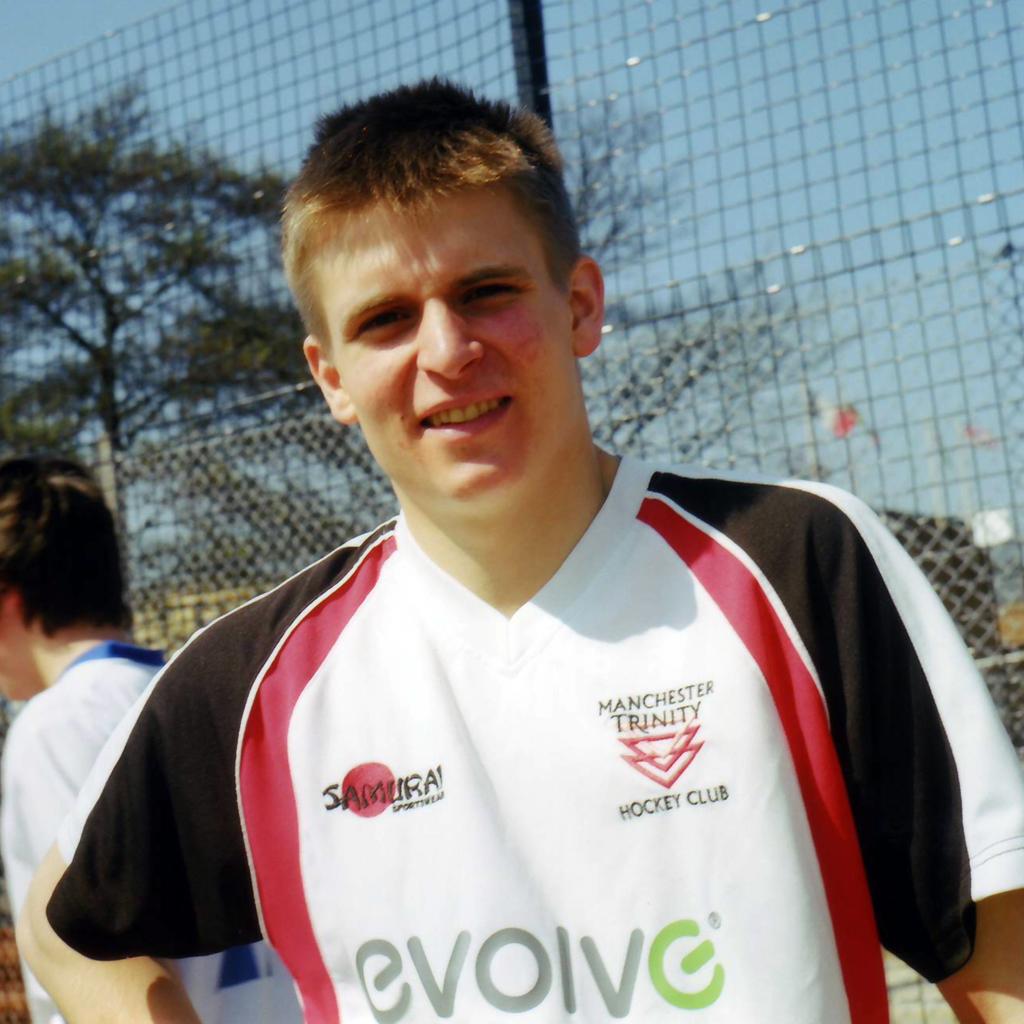What club does this man play for?
Provide a short and direct response. Manchester trinity. 